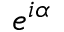<formula> <loc_0><loc_0><loc_500><loc_500>e ^ { i \alpha }</formula> 